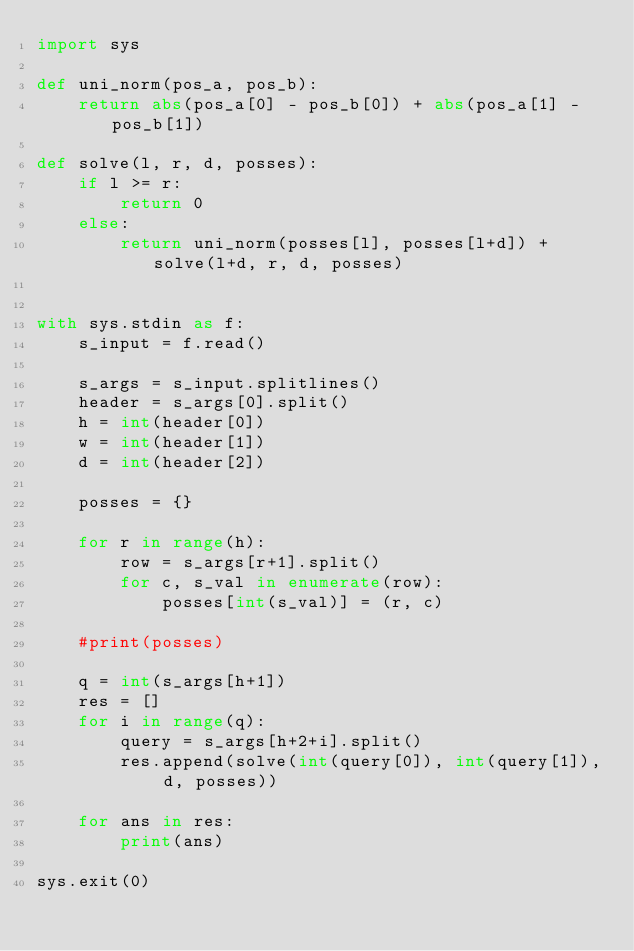<code> <loc_0><loc_0><loc_500><loc_500><_Python_>import sys

def uni_norm(pos_a, pos_b):
    return abs(pos_a[0] - pos_b[0]) + abs(pos_a[1] - pos_b[1])

def solve(l, r, d, posses):
    if l >= r:
        return 0
    else:
        return uni_norm(posses[l], posses[l+d]) + solve(l+d, r, d, posses)


with sys.stdin as f:
    s_input = f.read()

    s_args = s_input.splitlines()
    header = s_args[0].split()
    h = int(header[0])
    w = int(header[1])
    d = int(header[2])

    posses = {}
    
    for r in range(h):
        row = s_args[r+1].split()
        for c, s_val in enumerate(row):
            posses[int(s_val)] = (r, c)

    #print(posses)

    q = int(s_args[h+1])
    res = []
    for i in range(q):
        query = s_args[h+2+i].split()
        res.append(solve(int(query[0]), int(query[1]), d, posses))

    for ans in res:
        print(ans)
            
sys.exit(0)
</code> 